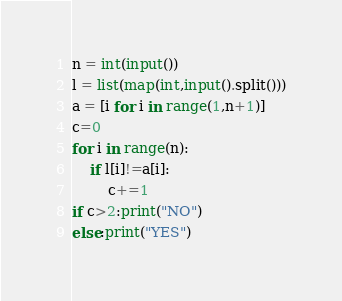<code> <loc_0><loc_0><loc_500><loc_500><_Python_>n = int(input())
l = list(map(int,input().split()))
a = [i for i in range(1,n+1)]
c=0
for i in range(n):
    if l[i]!=a[i]:
        c+=1
if c>2:print("NO")
else:print("YES")</code> 